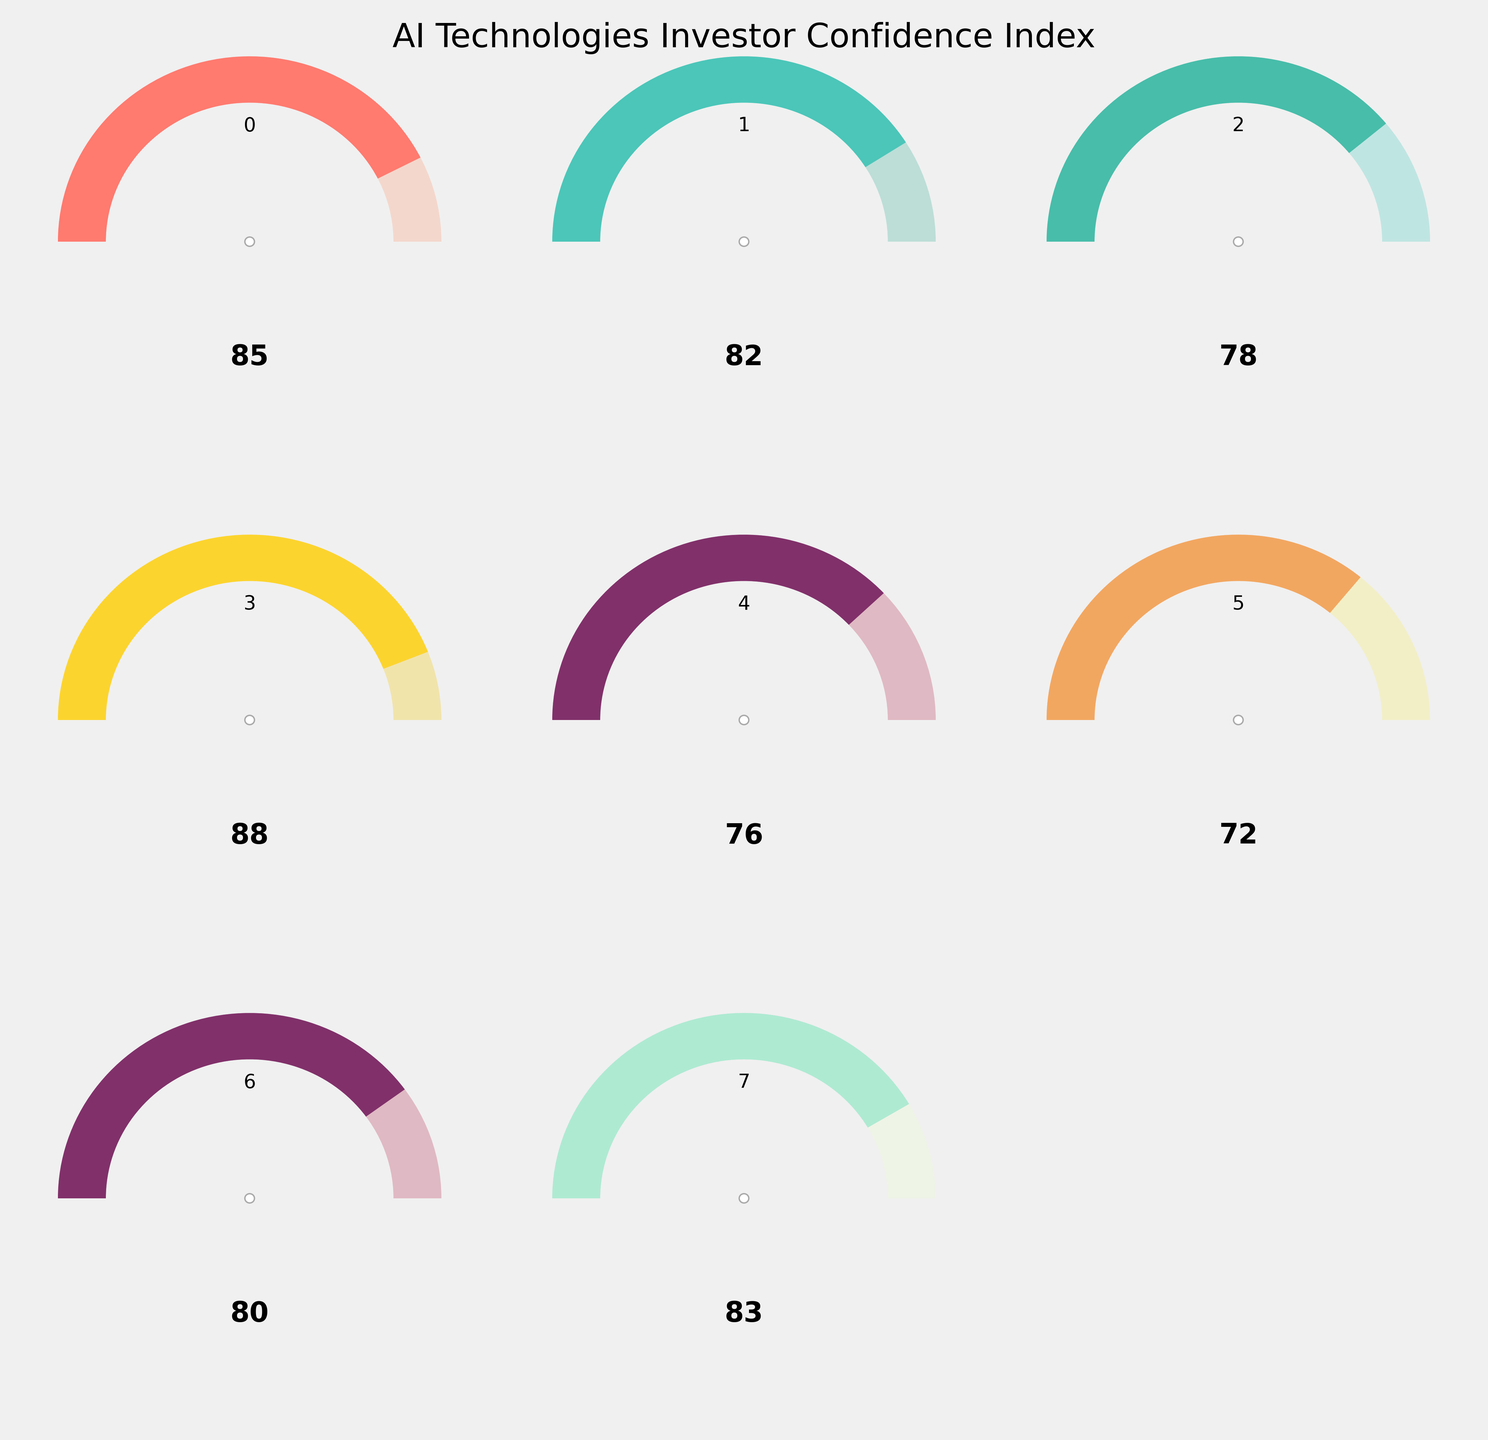What's the title of the figure? The title is placed at the top of the figure and readable in large font size, indicating the overall theme of the chart.
Answer: AI Technologies Investor Confidence Index How many gauge charts are displayed in total? There are 8 individual gauge charts presented in a 3x3 layout, with the bottom-right chart absent.
Answer: 8 Which AI technology has the highest confidence index? By observing the value at the bottom part of each gauge chart, the one with the highest number can be identified, which appears to be Google AI.
Answer: Google AI Confidence What is the confidence index value for OpenAI? The confidence index value is clearly stated within the gauge chart labeled 'OpenAI Confidence'.
Answer: 85 How does Meta AI's confidence compare to NVIDIA AI's confidence? By comparing the values listed on both 'Meta AI Confidence' and 'NVIDIA AI Confidence' gauge charts, we can note a difference. Meta AI is lower.
Answer: Meta AI's confidence is lower than NVIDIA AI's What is the average confidence index value among OpenAI, DeepMind, and Anthropic? First, add the values: 85 (OpenAI) + 82 (DeepMind) + 78 (Anthropic) = 245. Then, divide by the number of companies: 245 / 3 = 81.67.
Answer: 81.67 Which AI company's confidence is closest to the overall AI sector confidence? We compare the value of the 'Overall AI Sector Confidence' with each company's individual value, the closest one is DeepMind with 82.
Answer: DeepMind Confidence How much higher is Google AI's confidence than IBM Watson's confidence? The difference can be calculated by subtracting IBM Watson's value (72) from Google AI's value (88): 88 - 72 = 16.
Answer: 16 What is the median value of the AI technologies' confidence indices? First, arrange the values: 72, 76, 78, 80, 82, 85, 88. With 7 values, the median is the 4th value, which is 80.
Answer: 80 Which AI technologies have a confidence index above 80? By examining each gauge chart and checking the values, the ones above 80 are OpenAI, DeepMind, Google AI, and NVIDIA.
Answer: OpenAI, DeepMind, Google AI, NVIDIA 